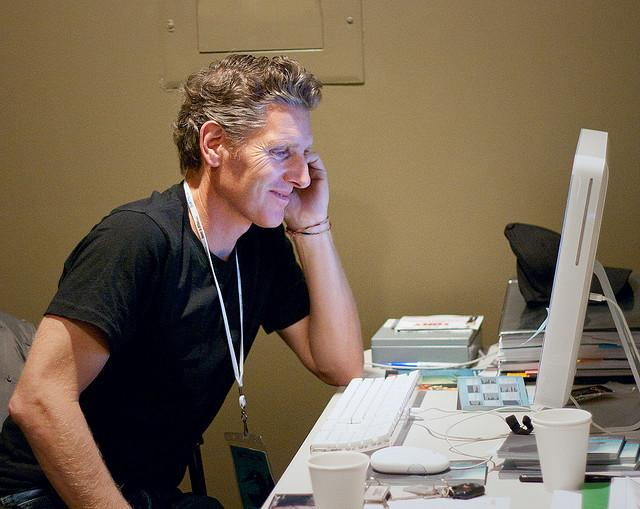What is closest to the computer screen? Please explain your reasoning. cup. There is a vessel for drinking next to the screen. 